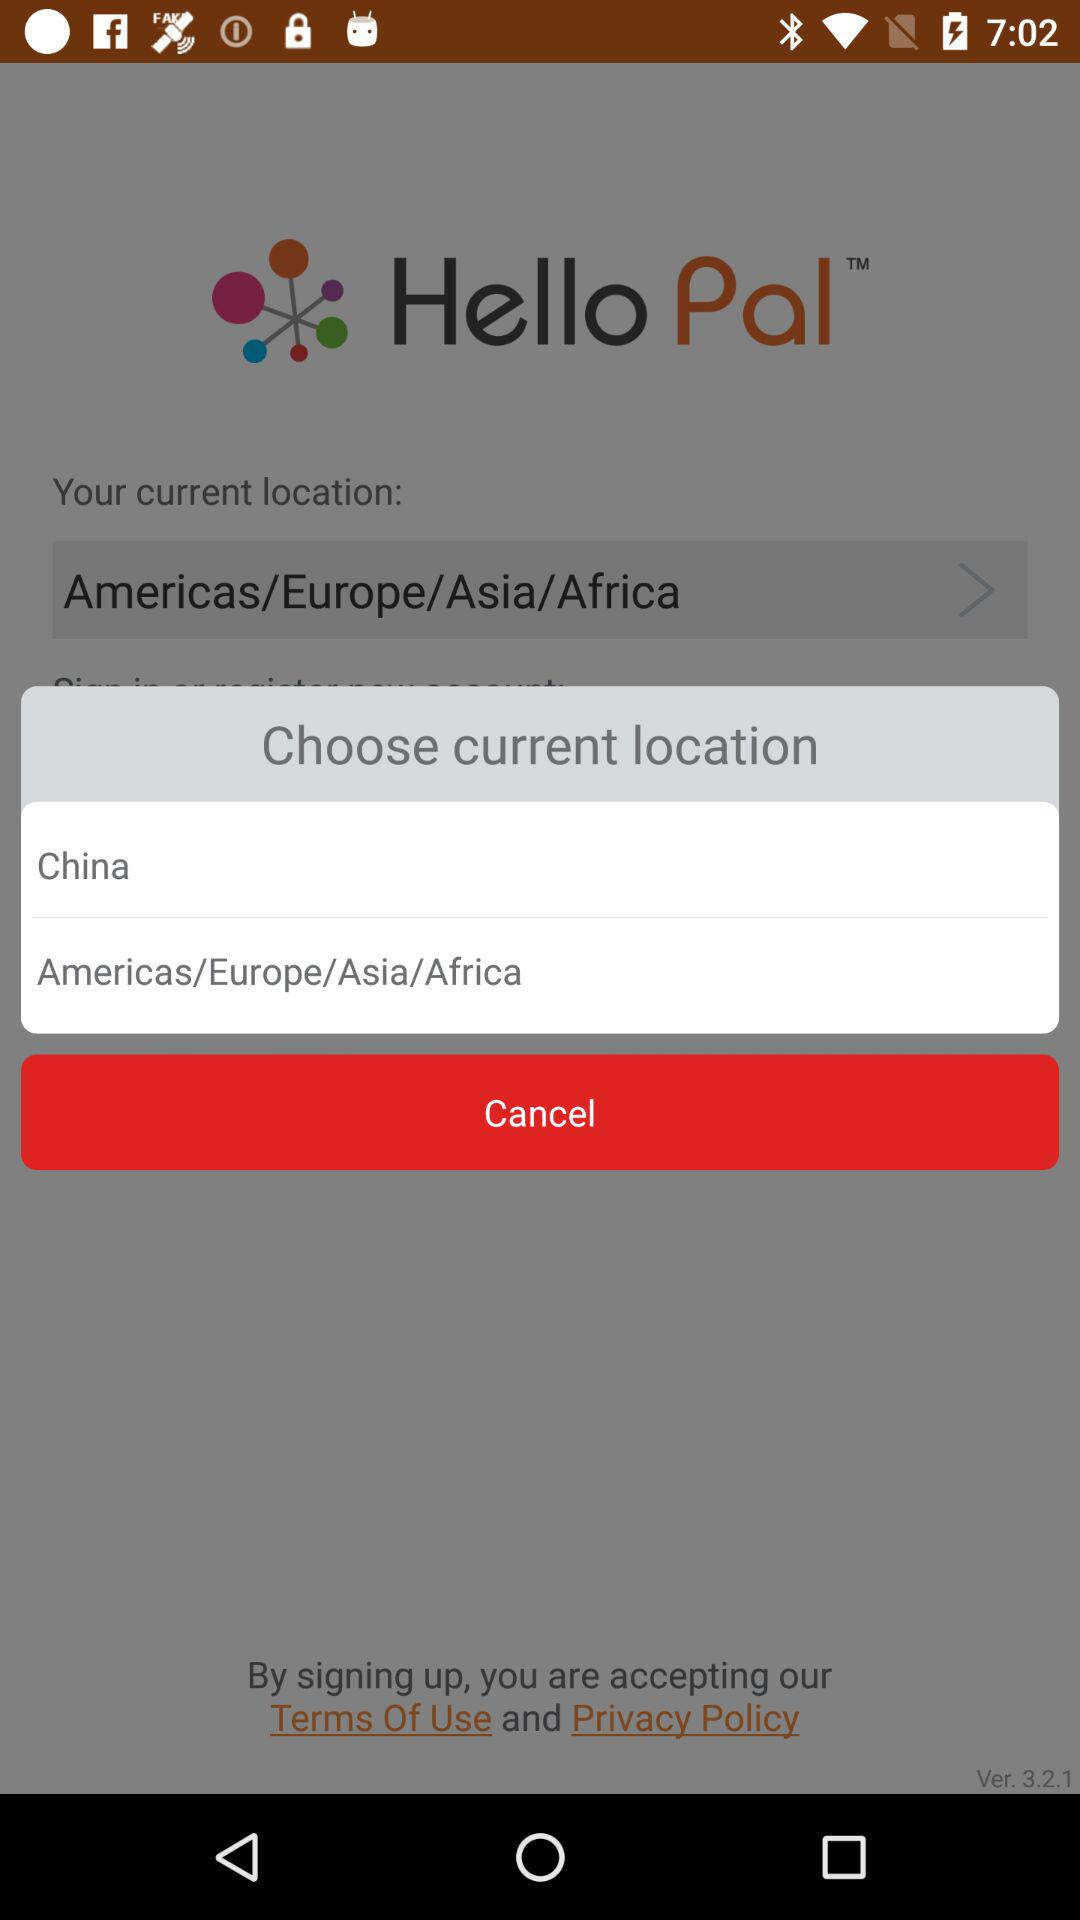What are the current locations given to choose from? The current locations are: "China" and "Americas/Europe/Asia/Africa". 